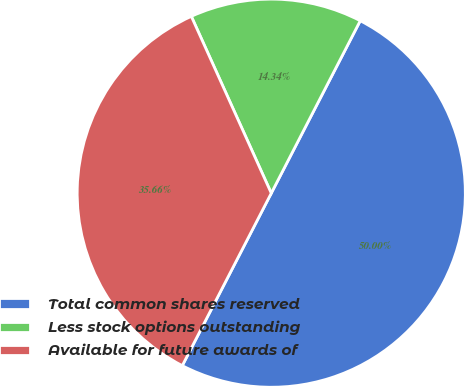<chart> <loc_0><loc_0><loc_500><loc_500><pie_chart><fcel>Total common shares reserved<fcel>Less stock options outstanding<fcel>Available for future awards of<nl><fcel>50.0%<fcel>14.34%<fcel>35.66%<nl></chart> 